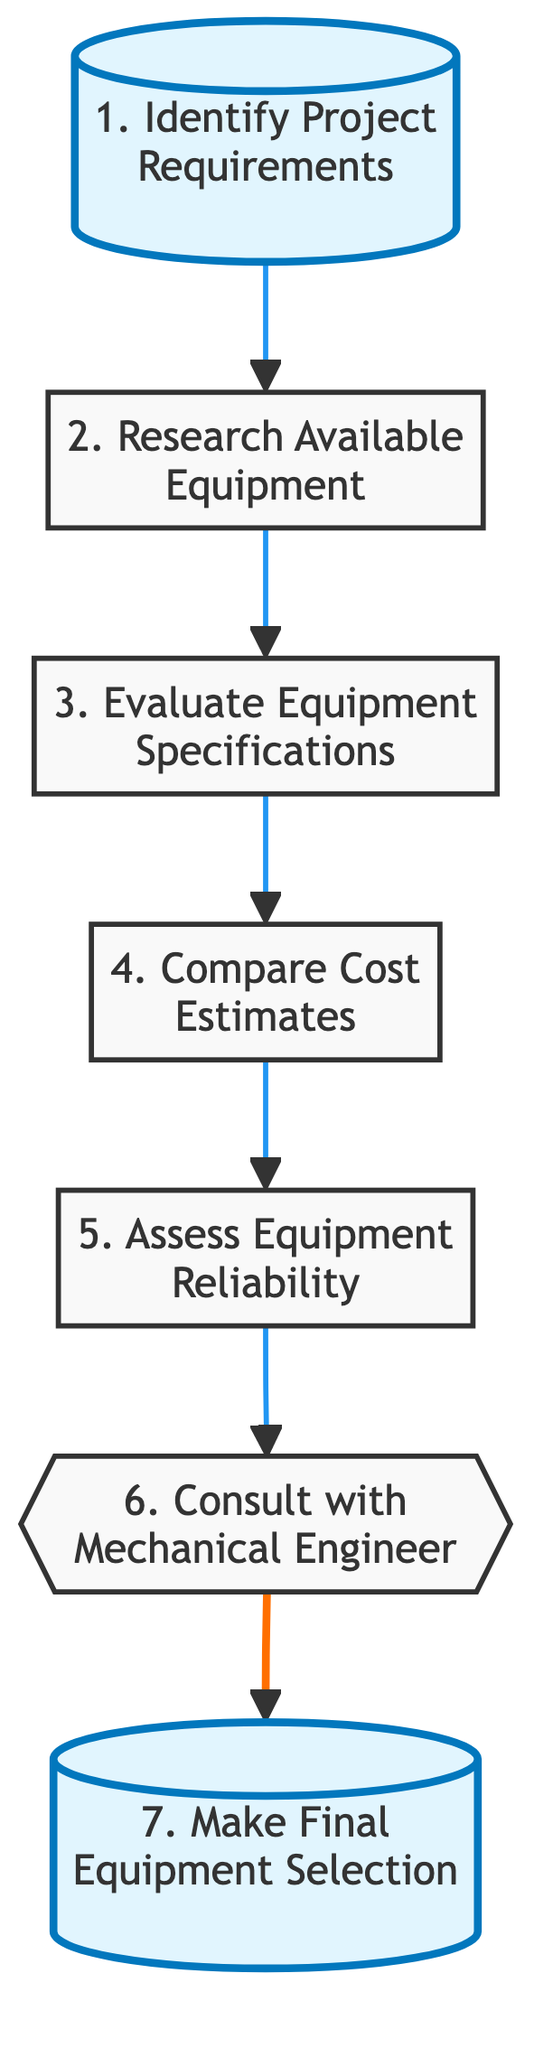What is the first step in the flow chart? The first step, according to the flow chart, is “Identify Project Requirements”. It is the initial action indicating the starting point of the evaluation process.
Answer: Identify Project Requirements How many main steps are there in the diagram? Counting the elements in the flow chart, there are seven main steps that outline the equipment evaluation process.
Answer: Seven What is the last step in the flow chart? The last step, as shown in the flow chart, is “Make Final Equipment Selection”. It concludes the sequence after all evaluations and consultations.
Answer: Make Final Equipment Selection Which step follows “Evaluate Equipment Specifications”? The step that directly follows “Evaluate Equipment Specifications” is “Compare Cost Estimates”. This indicates the next action to be taken after evaluating specifications.
Answer: Compare Cost Estimates How many steps involve cost assessments? There are two steps that involve cost assessments: “Compare Cost Estimates” and the costs associated with “Assess Equipment Reliability”. Thus, the total is two steps.
Answer: Two In which step is the mechanical engineer consulted? The mechanical engineer is consulted in the step labeled “Consult with Mechanical Engineer”. This step emphasizes the need for expert input before making a decision.
Answer: Consult with Mechanical Engineer What is the relationship between “Assess Equipment Reliability” and “Make Final Equipment Selection”? “Assess Equipment Reliability” is a prerequisite to “Make Final Equipment Selection”. This indicates that reliability evaluation must occur before the final choice is made.
Answer: Prerequisite What type of flow does the diagram illustrate? The diagram illustrates a linear flow, indicating a sequential and ordered process for evaluating and selecting equipment. Each step leads to the next in a direct manner.
Answer: Linear flow What color highlights the first and last steps in the flow chart? The first and last steps are highlighted in a blue shade, which visually differentiates them from the other steps in the diagram.
Answer: Blue 